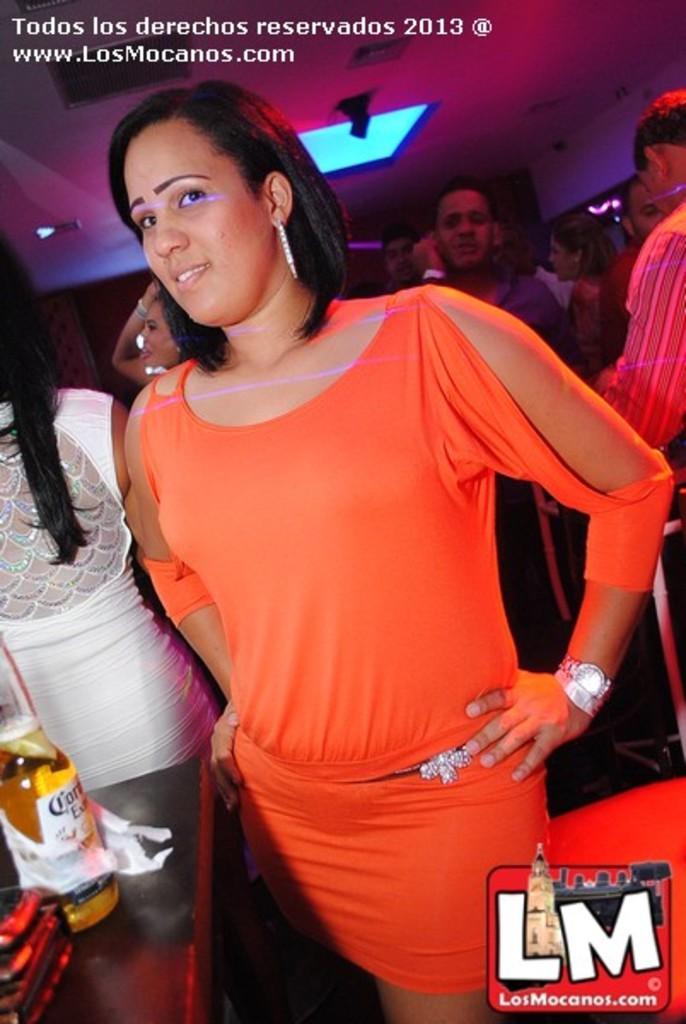Could you give a brief overview of what you see in this image? In this picture we can see a group of people standing. At the top there is a ceiling light. On the left side of the image there is a bottle and some objects on the table. On the image there are watermarks. 